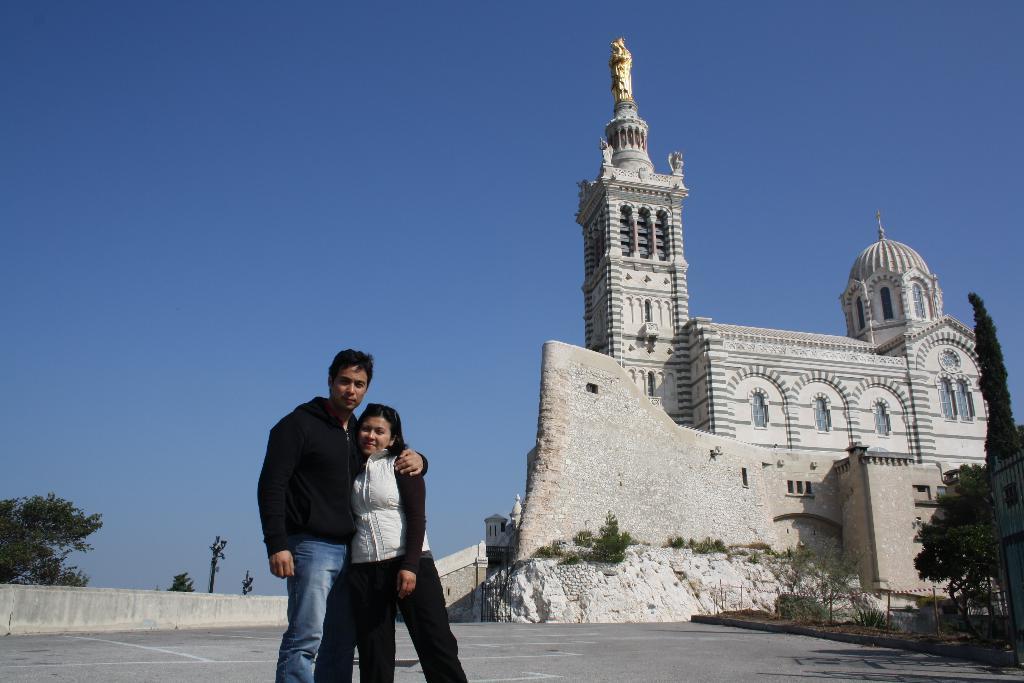Could you give a brief overview of what you see in this image? In the center of the image there are two persons standing. In the background of the image there is a church. There are trees. 